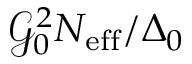Convert formula to latex. <formula><loc_0><loc_0><loc_500><loc_500>\mathcal { G } _ { 0 } ^ { 2 } N _ { e f f } / \Delta _ { 0 }</formula> 